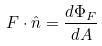<formula> <loc_0><loc_0><loc_500><loc_500>F \cdot \hat { n } = \frac { d \Phi _ { F } } { d A }</formula> 